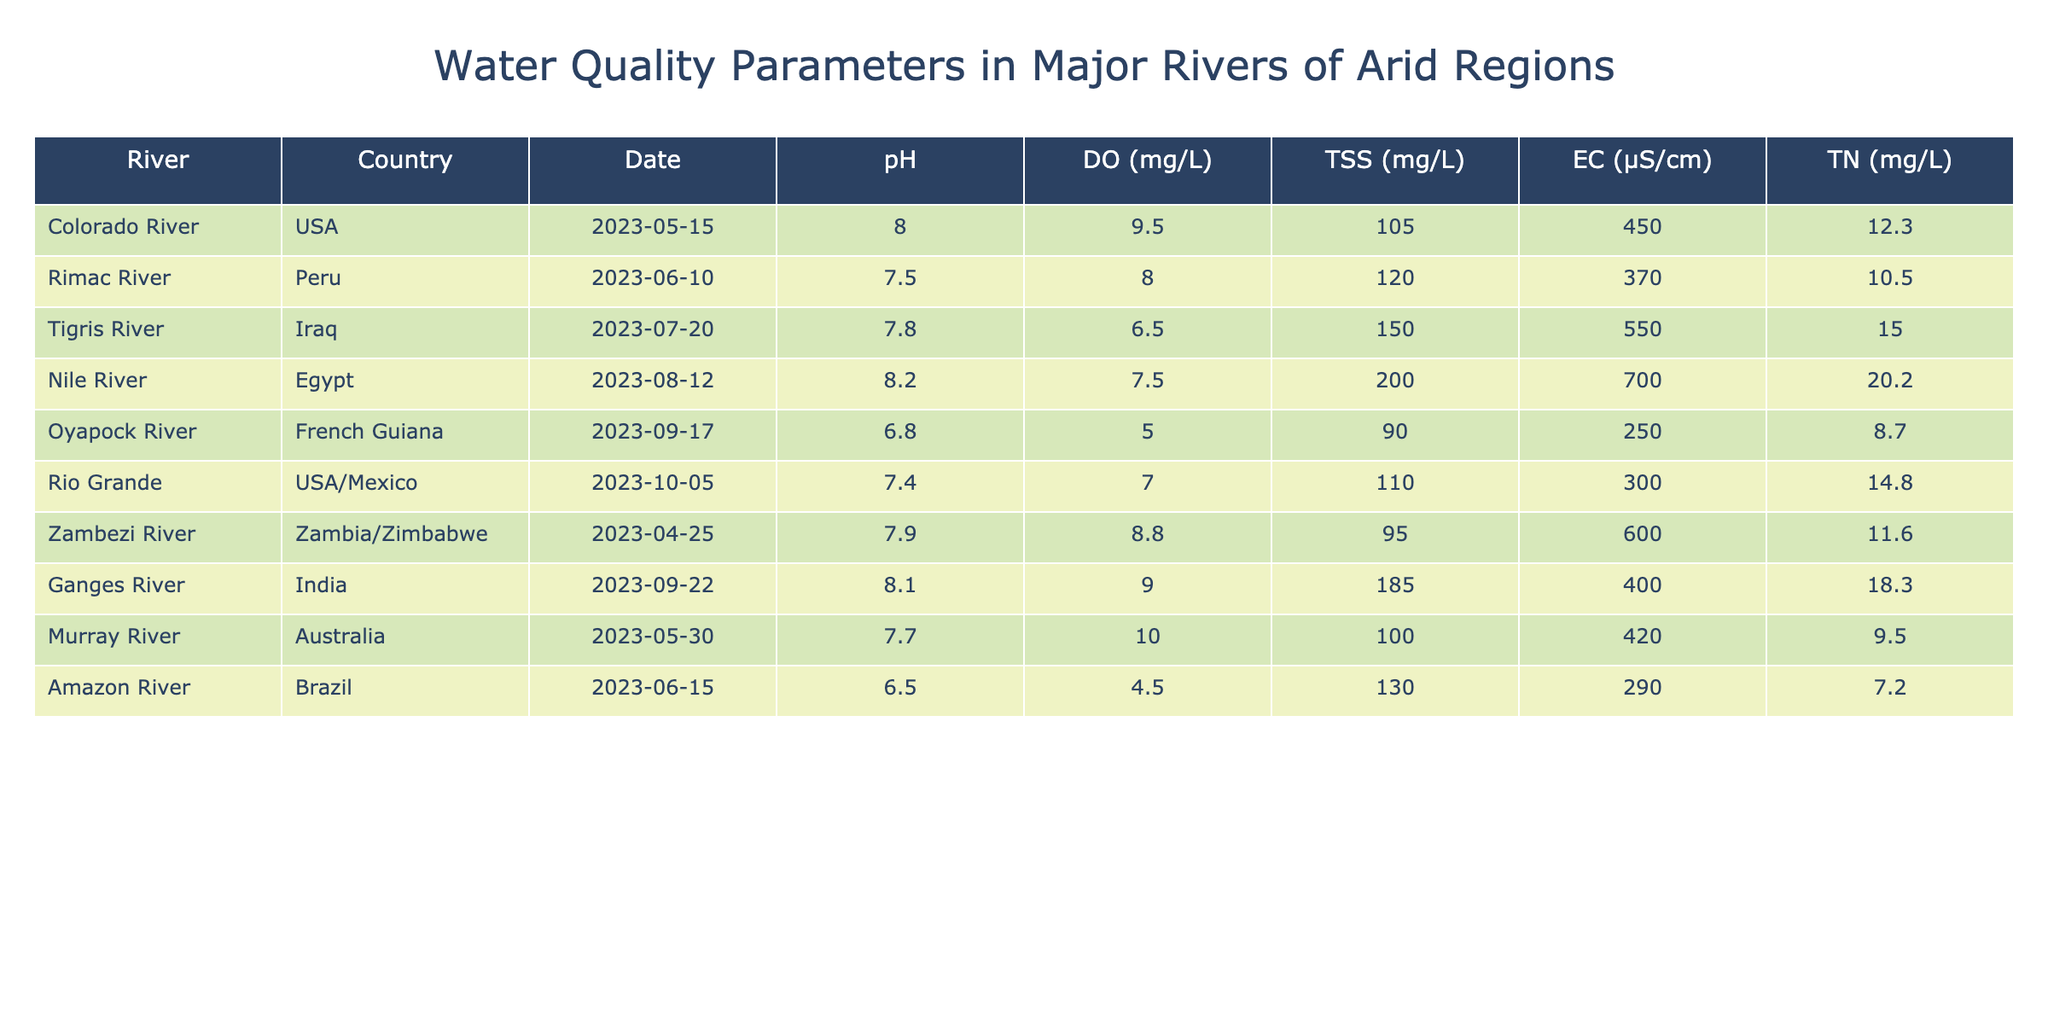What is the pH of the Nile River? From the table, we can directly locate the row for the Nile River and find that the pH value is listed as 8.2.
Answer: 8.2 Which river has the highest level of Total Suspended Solids? By inspecting the Total Suspended Solids (TSS) column, we see the highest value is 200 mg/L for the Nile River.
Answer: Nile River Is the Dissolved Oxygen level for the Ganges River above 10 mg/L? The table shows a Dissolved Oxygen level of 9.0 mg/L for the Ganges River, which is below 10 mg/L, making the statement false.
Answer: No What is the average Electrical Conductivity for the rivers listed? First, we sum the Electrical Conductivity values: 450 + 370 + 550 + 700 + 250 + 300 + 600 + 420 + 290 = 3980. There are 9 rivers, so the average is 3980 / 9 ≈ 442.22 µS/cm.
Answer: Approximately 442.22 µS/cm Which river has the lowest Total Nutrients level? Looking through the Total Nutrients column, the Oyapock River has the lowest value at 8.7 mg/L.
Answer: Oyapock River How does the Dissolved Oxygen compare between the Colorado River and the Zambezi River? The Colorado River has a Dissolved Oxygen level of 9.5 mg/L while the Zambezi River has 8.8 mg/L. Therefore, the Colorado River has a higher level of Dissolved Oxygen than the Zambezi River.
Answer: Colorado River is higher What is the total amount of Total Nutrients for all the rivers measured? Adding the Total Nutrients values together gives us: 12.3 + 10.5 + 15.0 + 20.2 + 8.7 + 14.8 + 11.6 + 18.3 + 9.5 = 132.0 mg/L.
Answer: 132.0 mg/L Which river had the measurement taken on June 10, 2023, and what was the pH at that time? The Rimac River is the only river with a measurement date of June 10, 2023, and its pH was 7.5.
Answer: Rimac River, pH 7.5 Are there any rivers listed from the USA? If so, name one. Yes, both the Colorado River and the Rio Grande are listed from the USA. Therefore, at least one river is from the USA.
Answer: Yes, Colorado River Calculate the difference in Total Suspended Solids between the Nile River and the Oyapock River. The Total Suspended Solids for the Nile River is 200 mg/L and for the Oyapock River it is 90 mg/L. Therefore, the difference is 200 - 90 = 110 mg/L.
Answer: 110 mg/L What country is associated with the river that has the highest Total Nutrients? The river with the highest Total Nutrients is the Nile River at 20.2 mg/L, which is associated with Egypt.
Answer: Egypt 